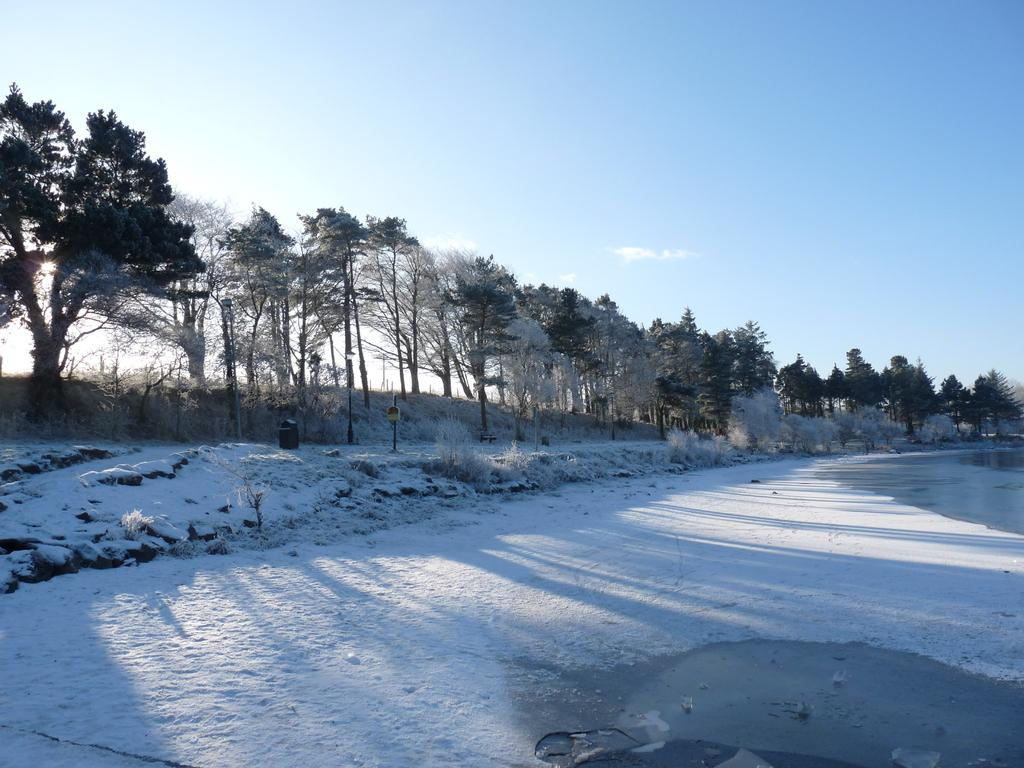What is the condition of the land in the image? The land in the image is covered with snow. What can be seen in the background of the image? There are trees and a blue sky in the background of the image. Where is the nest of the bird in the image? There is no nest or bird present in the image. What type of engine can be seen powering the snowmobile in the image? There is no snowmobile or engine present in the image. 